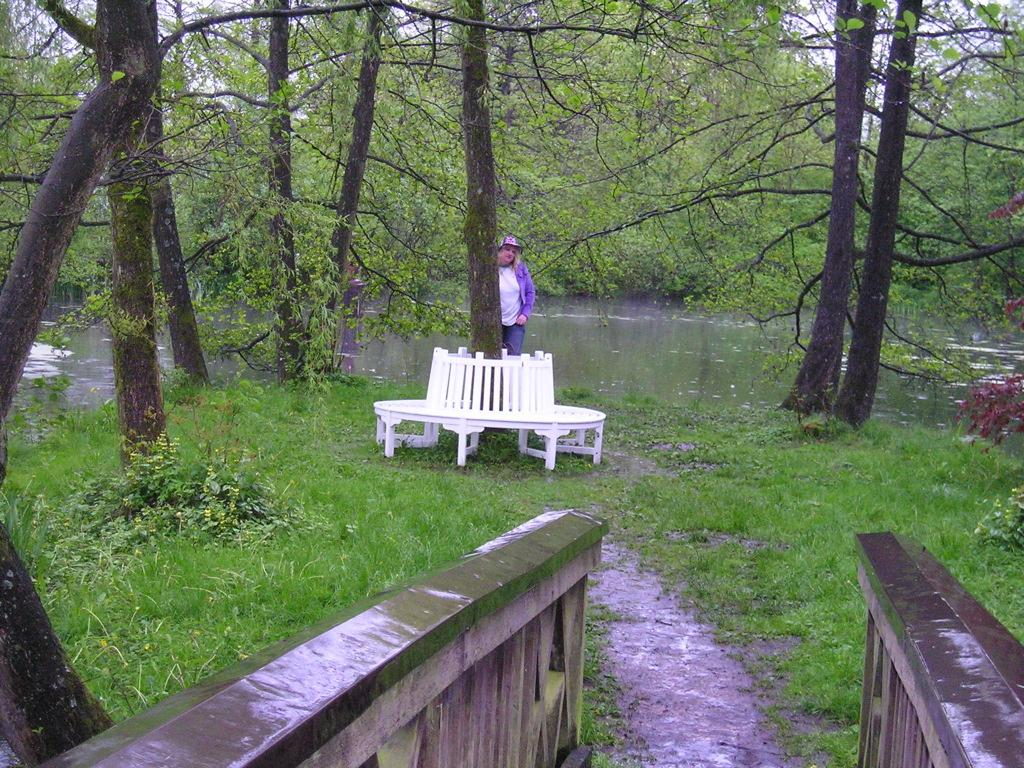What type of vegetation can be seen in the image? There are trees in the image. Can you describe the person's position in relation to the tree? A person is standing behind a tree. What type of furniture is near the tree? There are chairs near the tree. What architectural features can be seen in the background of the image? There are walls in the background of the image. What type of ground cover is visible in the background of the image? Grass is present in the background of the image. What natural element is visible in the background of the image? There is water visible in the background of the image. What part of the natural environment is visible in the background of the image? The sky is visible in the background of the image. What type of cheese is being served on the chair in the image? There is no cheese present in the image, and no food is mentioned in the provided facts. 